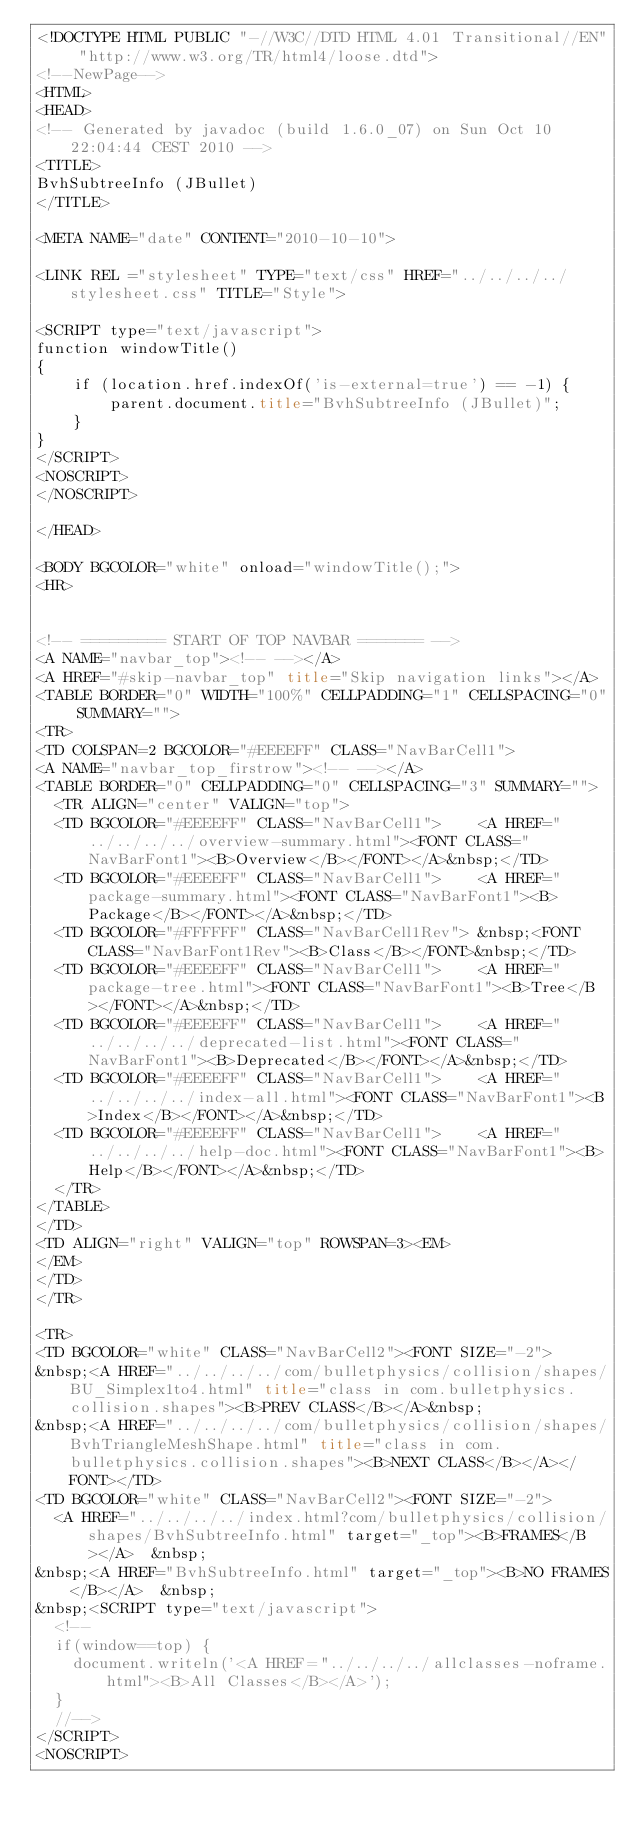<code> <loc_0><loc_0><loc_500><loc_500><_HTML_><!DOCTYPE HTML PUBLIC "-//W3C//DTD HTML 4.01 Transitional//EN" "http://www.w3.org/TR/html4/loose.dtd">
<!--NewPage-->
<HTML>
<HEAD>
<!-- Generated by javadoc (build 1.6.0_07) on Sun Oct 10 22:04:44 CEST 2010 -->
<TITLE>
BvhSubtreeInfo (JBullet)
</TITLE>

<META NAME="date" CONTENT="2010-10-10">

<LINK REL ="stylesheet" TYPE="text/css" HREF="../../../../stylesheet.css" TITLE="Style">

<SCRIPT type="text/javascript">
function windowTitle()
{
    if (location.href.indexOf('is-external=true') == -1) {
        parent.document.title="BvhSubtreeInfo (JBullet)";
    }
}
</SCRIPT>
<NOSCRIPT>
</NOSCRIPT>

</HEAD>

<BODY BGCOLOR="white" onload="windowTitle();">
<HR>


<!-- ========= START OF TOP NAVBAR ======= -->
<A NAME="navbar_top"><!-- --></A>
<A HREF="#skip-navbar_top" title="Skip navigation links"></A>
<TABLE BORDER="0" WIDTH="100%" CELLPADDING="1" CELLSPACING="0" SUMMARY="">
<TR>
<TD COLSPAN=2 BGCOLOR="#EEEEFF" CLASS="NavBarCell1">
<A NAME="navbar_top_firstrow"><!-- --></A>
<TABLE BORDER="0" CELLPADDING="0" CELLSPACING="3" SUMMARY="">
  <TR ALIGN="center" VALIGN="top">
  <TD BGCOLOR="#EEEEFF" CLASS="NavBarCell1">    <A HREF="../../../../overview-summary.html"><FONT CLASS="NavBarFont1"><B>Overview</B></FONT></A>&nbsp;</TD>
  <TD BGCOLOR="#EEEEFF" CLASS="NavBarCell1">    <A HREF="package-summary.html"><FONT CLASS="NavBarFont1"><B>Package</B></FONT></A>&nbsp;</TD>
  <TD BGCOLOR="#FFFFFF" CLASS="NavBarCell1Rev"> &nbsp;<FONT CLASS="NavBarFont1Rev"><B>Class</B></FONT>&nbsp;</TD>
  <TD BGCOLOR="#EEEEFF" CLASS="NavBarCell1">    <A HREF="package-tree.html"><FONT CLASS="NavBarFont1"><B>Tree</B></FONT></A>&nbsp;</TD>
  <TD BGCOLOR="#EEEEFF" CLASS="NavBarCell1">    <A HREF="../../../../deprecated-list.html"><FONT CLASS="NavBarFont1"><B>Deprecated</B></FONT></A>&nbsp;</TD>
  <TD BGCOLOR="#EEEEFF" CLASS="NavBarCell1">    <A HREF="../../../../index-all.html"><FONT CLASS="NavBarFont1"><B>Index</B></FONT></A>&nbsp;</TD>
  <TD BGCOLOR="#EEEEFF" CLASS="NavBarCell1">    <A HREF="../../../../help-doc.html"><FONT CLASS="NavBarFont1"><B>Help</B></FONT></A>&nbsp;</TD>
  </TR>
</TABLE>
</TD>
<TD ALIGN="right" VALIGN="top" ROWSPAN=3><EM>
</EM>
</TD>
</TR>

<TR>
<TD BGCOLOR="white" CLASS="NavBarCell2"><FONT SIZE="-2">
&nbsp;<A HREF="../../../../com/bulletphysics/collision/shapes/BU_Simplex1to4.html" title="class in com.bulletphysics.collision.shapes"><B>PREV CLASS</B></A>&nbsp;
&nbsp;<A HREF="../../../../com/bulletphysics/collision/shapes/BvhTriangleMeshShape.html" title="class in com.bulletphysics.collision.shapes"><B>NEXT CLASS</B></A></FONT></TD>
<TD BGCOLOR="white" CLASS="NavBarCell2"><FONT SIZE="-2">
  <A HREF="../../../../index.html?com/bulletphysics/collision/shapes/BvhSubtreeInfo.html" target="_top"><B>FRAMES</B></A>  &nbsp;
&nbsp;<A HREF="BvhSubtreeInfo.html" target="_top"><B>NO FRAMES</B></A>  &nbsp;
&nbsp;<SCRIPT type="text/javascript">
  <!--
  if(window==top) {
    document.writeln('<A HREF="../../../../allclasses-noframe.html"><B>All Classes</B></A>');
  }
  //-->
</SCRIPT>
<NOSCRIPT></code> 